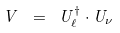<formula> <loc_0><loc_0><loc_500><loc_500>V \ = \ U _ { \ell } ^ { \dagger } \cdot U _ { \nu }</formula> 